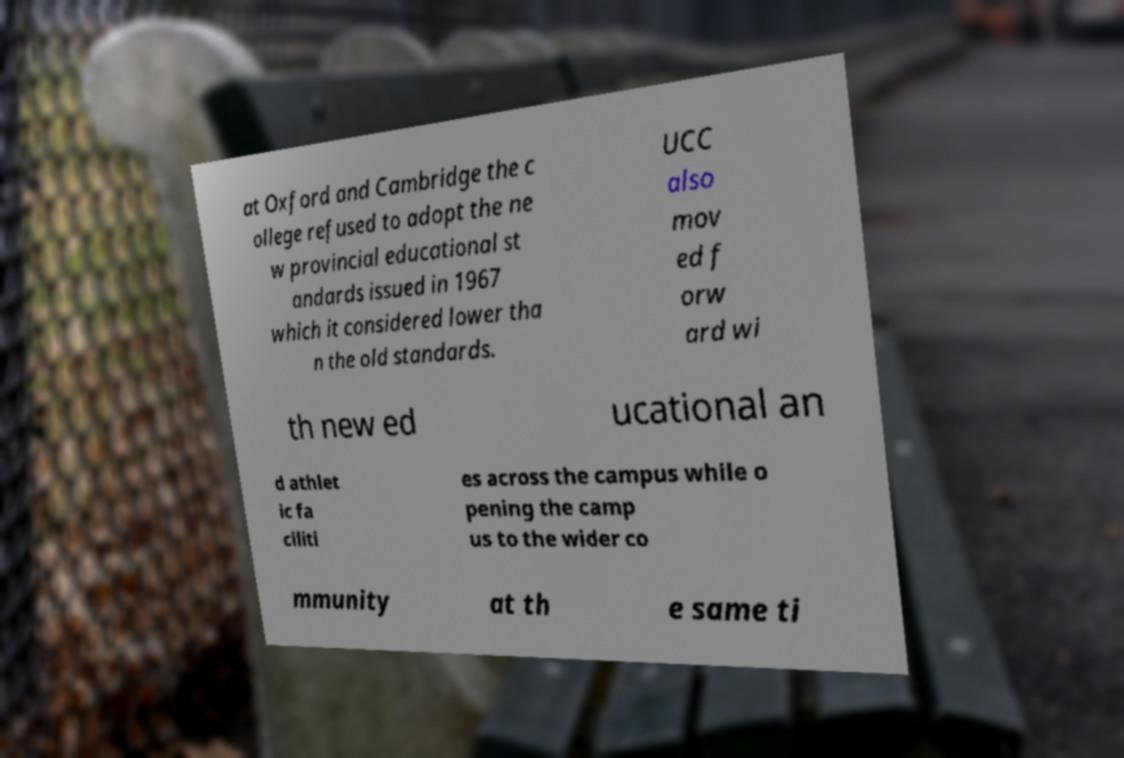Could you extract and type out the text from this image? at Oxford and Cambridge the c ollege refused to adopt the ne w provincial educational st andards issued in 1967 which it considered lower tha n the old standards. UCC also mov ed f orw ard wi th new ed ucational an d athlet ic fa ciliti es across the campus while o pening the camp us to the wider co mmunity at th e same ti 